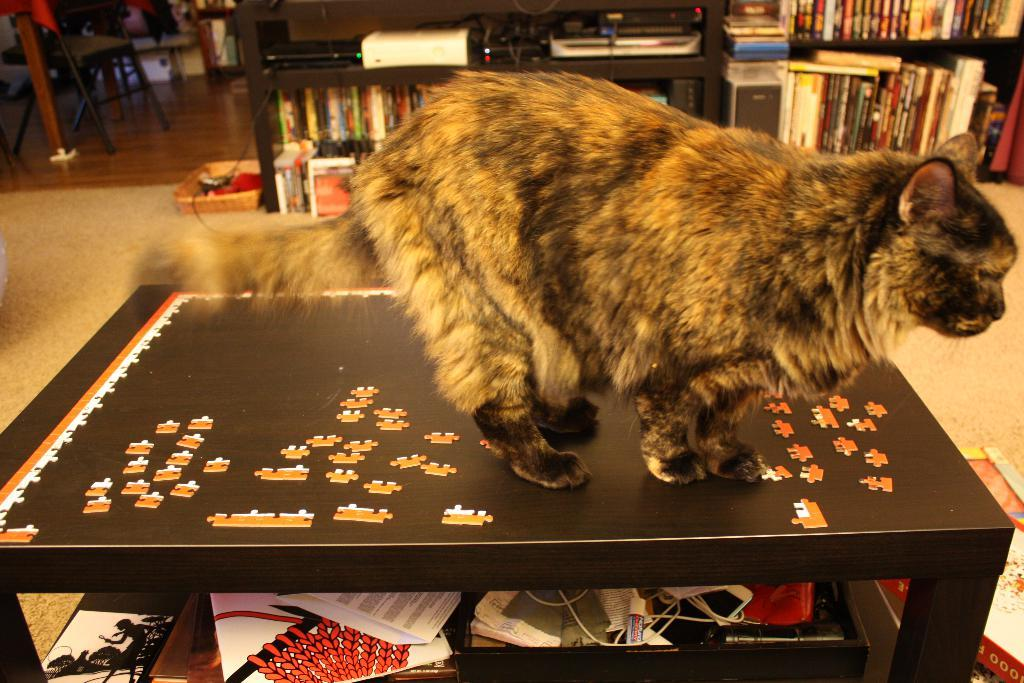What type of animal is on the table in the image? There is a cat on the table in the image. What can be seen on the shelves in the image? There are books on shelves in the image. What type of electronic items are present in the image? There are devices present in the image. What type of wiring is visible in the image? Cables are visible in the image. What type of container is in the image? There is a basket in the image. What type of furniture is on the floor in the image? A chair is on the floor in the image. What other objects can be seen in the image? There are additional objects in the image. What type of net is being used to catch the cat in the image? There is no net present in the image, and the cat is not being caught. What type of humor is being displayed by the cat in the image? There is no humor being displayed by the cat in the image; it is simply sitting on the table. 